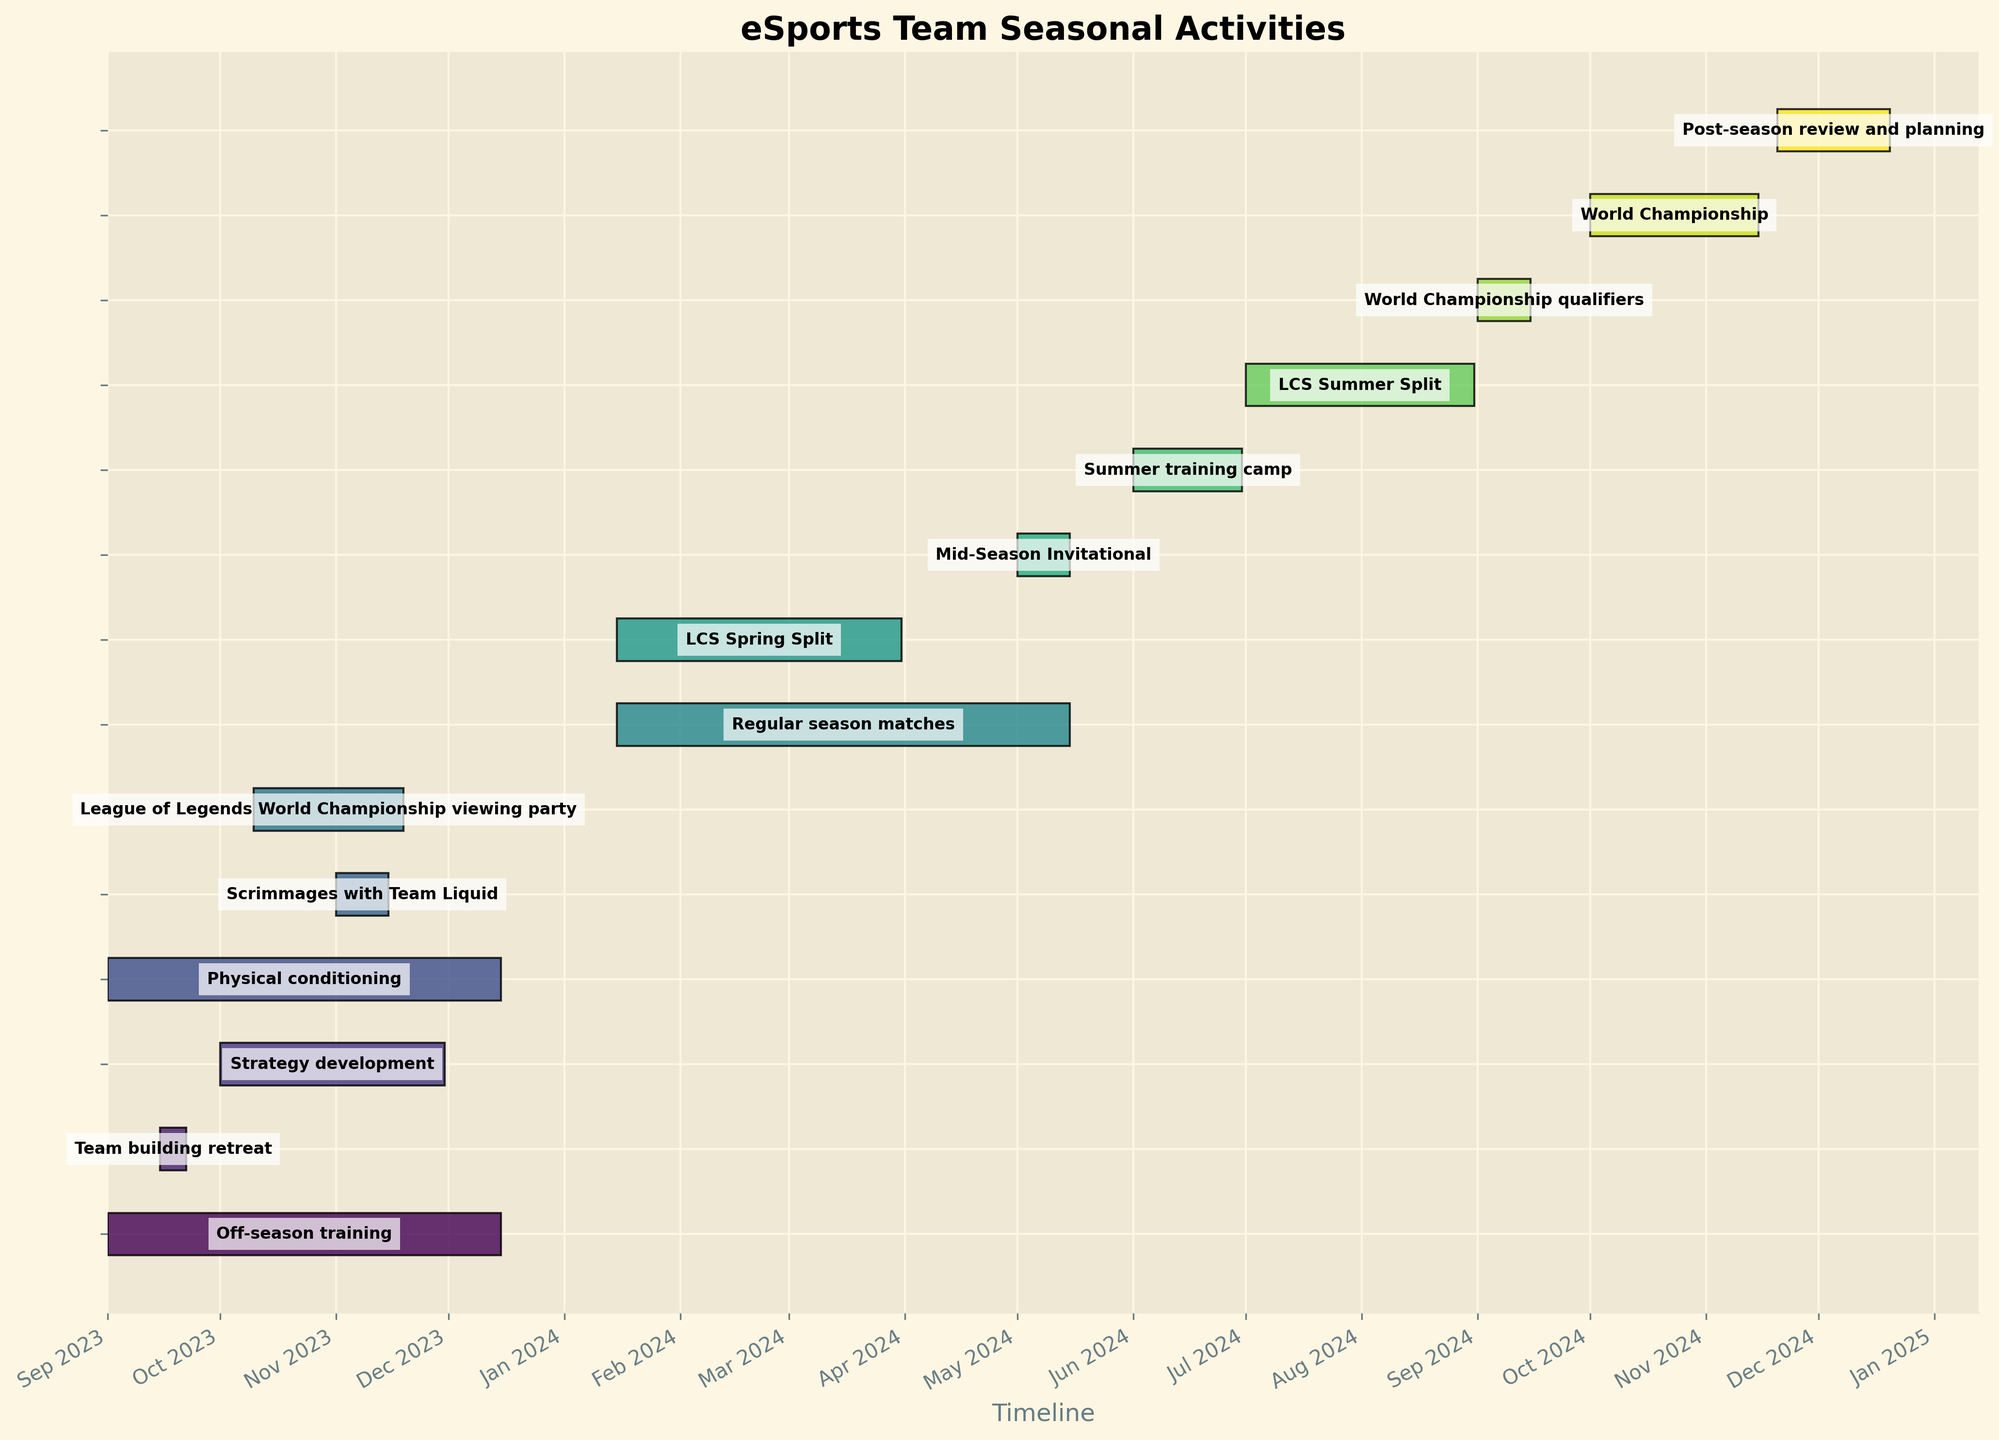What is the title of the figure? The title is usually placed at the top of the chart. In this figure, it is prominently displayed in a larger font size to indicate the subject of the visualization.
Answer: "eSports Team Seasonal Activities" Which task takes place in both September and October 2023? To find tasks spanning both months, look for bars that start in September and end after the start of October. The "Team building retreat" starts on 2023-09-15 and ends on 2023-09-22, so it does not fit the criteria. However, "Strategy development" starts on 2023-10-01 and ends on 2023-11-30, which is also incorrect. Only "Off-season training" fits this range.
Answer: "Off-season training" How many tasks start in 2024? To find the tasks that begin in 2024, check each bar’s start date. The tasks "Regular season matches," "LCS Spring Split," "Mid-Season Invitational," "Summer training camp," "LCS Summer Split," "World Championship qualifiers," "World Championship," and "Post-season review and planning" all start in 2024.
Answer: 8 When does the "World Championship" end? Locate the bar representing the "World Championship" and check its end date on the right side. According to the timeline, it starts on 2024-10-01 and ends on 2024-11-15.
Answer: 2024-11-15 What is the duration of the "Summer training camp"? Determine the duration by finding the number of days between the start and end dates. The "Summer training camp" starts on 2024-06-01 and ends on 2024-06-30. Hence, the duration is 30 days.
Answer: 30 days Which is longer, the "Off-season training" or the "LCS Summer Split"? Compare the duration of both events. The "Off-season training" spans from 2023-09-01 to 2023-12-15, and "LCS Summer Split" from 2024-07-01 to 2024-08-31. The "Off-season training" lasts for 106 days, while the "LCS Summer Split" lasts for 62 days.
Answer: Off-season training What events overlap with the "Strategy development" period? Locate "Strategy development" from 2023-10-01 to 2023-11-30 and identify tasks occurring during this period. Tasks overlapping are "Off-season training," "Physical conditioning," "Scrimmages with Team Liquid," and "League of Legends World Championship viewing party."
Answer: Off-season training, Physical conditioning, Scrimmages with Team Liquid, League of Legends World Championship viewing party How does the number of tasks in the regular season compare to the off-season? Count the tasks in both periods. In the off-season (September to December 2023), there are "Off-season training," "Team building retreat," "Strategy development," "Physical conditioning," "Scrimmages with Team Liquid," and "League of Legends World Championship viewing party" (6 tasks). In the regular season (January to May 2024), there are "Regular season matches," "LCS Spring Split," and "Mid-Season Invitational" (3 tasks).
Answer: The off-season has more tasks What is the time gap between the end of "Regular season matches" and the start of "LCS Summer Split"? Check the end date of "Regular season matches" (2024-05-15) and the start date of "LCS Summer Split" (2024-07-01). The gap is from 2024-05-15 to 2024-07-01, which is 46 days.
Answer: 46 days 